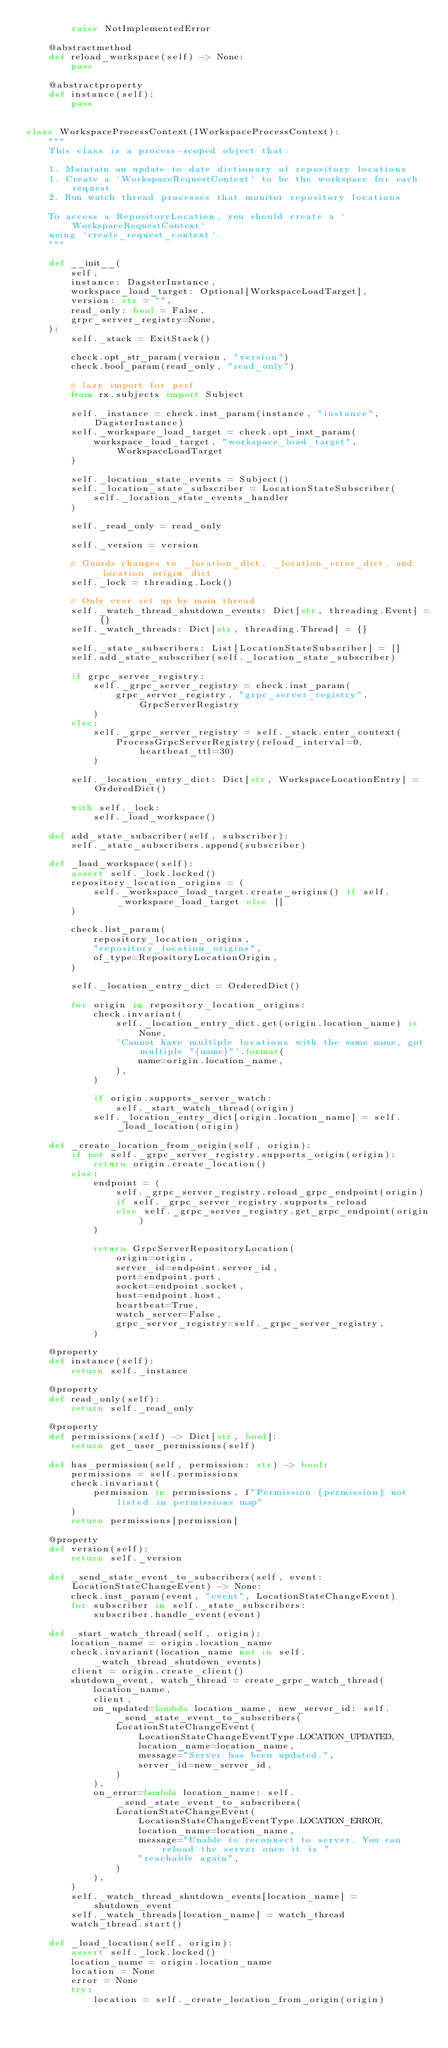<code> <loc_0><loc_0><loc_500><loc_500><_Python_>        raise NotImplementedError

    @abstractmethod
    def reload_workspace(self) -> None:
        pass

    @abstractproperty
    def instance(self):
        pass


class WorkspaceProcessContext(IWorkspaceProcessContext):
    """
    This class is a process-scoped object that:

    1. Maintain an update-to-date dictionary of repository locations
    1. Create a `WorkspaceRequestContext` to be the workspace for each request
    2. Run watch thread processes that monitor repository locations

    To access a RepositoryLocation, you should create a `WorkspaceRequestContext`
    using `create_request_context`.
    """

    def __init__(
        self,
        instance: DagsterInstance,
        workspace_load_target: Optional[WorkspaceLoadTarget],
        version: str = "",
        read_only: bool = False,
        grpc_server_registry=None,
    ):
        self._stack = ExitStack()

        check.opt_str_param(version, "version")
        check.bool_param(read_only, "read_only")

        # lazy import for perf
        from rx.subjects import Subject

        self._instance = check.inst_param(instance, "instance", DagsterInstance)
        self._workspace_load_target = check.opt_inst_param(
            workspace_load_target, "workspace_load_target", WorkspaceLoadTarget
        )

        self._location_state_events = Subject()
        self._location_state_subscriber = LocationStateSubscriber(
            self._location_state_events_handler
        )

        self._read_only = read_only

        self._version = version

        # Guards changes to _location_dict, _location_error_dict, and _location_origin_dict
        self._lock = threading.Lock()

        # Only ever set up by main thread
        self._watch_thread_shutdown_events: Dict[str, threading.Event] = {}
        self._watch_threads: Dict[str, threading.Thread] = {}

        self._state_subscribers: List[LocationStateSubscriber] = []
        self.add_state_subscriber(self._location_state_subscriber)

        if grpc_server_registry:
            self._grpc_server_registry = check.inst_param(
                grpc_server_registry, "grpc_server_registry", GrpcServerRegistry
            )
        else:
            self._grpc_server_registry = self._stack.enter_context(
                ProcessGrpcServerRegistry(reload_interval=0, heartbeat_ttl=30)
            )

        self._location_entry_dict: Dict[str, WorkspaceLocationEntry] = OrderedDict()

        with self._lock:
            self._load_workspace()

    def add_state_subscriber(self, subscriber):
        self._state_subscribers.append(subscriber)

    def _load_workspace(self):
        assert self._lock.locked()
        repository_location_origins = (
            self._workspace_load_target.create_origins() if self._workspace_load_target else []
        )

        check.list_param(
            repository_location_origins,
            "repository_location_origins",
            of_type=RepositoryLocationOrigin,
        )

        self._location_entry_dict = OrderedDict()

        for origin in repository_location_origins:
            check.invariant(
                self._location_entry_dict.get(origin.location_name) is None,
                'Cannot have multiple locations with the same name, got multiple "{name}"'.format(
                    name=origin.location_name,
                ),
            )

            if origin.supports_server_watch:
                self._start_watch_thread(origin)
            self._location_entry_dict[origin.location_name] = self._load_location(origin)

    def _create_location_from_origin(self, origin):
        if not self._grpc_server_registry.supports_origin(origin):
            return origin.create_location()
        else:
            endpoint = (
                self._grpc_server_registry.reload_grpc_endpoint(origin)
                if self._grpc_server_registry.supports_reload
                else self._grpc_server_registry.get_grpc_endpoint(origin)
            )

            return GrpcServerRepositoryLocation(
                origin=origin,
                server_id=endpoint.server_id,
                port=endpoint.port,
                socket=endpoint.socket,
                host=endpoint.host,
                heartbeat=True,
                watch_server=False,
                grpc_server_registry=self._grpc_server_registry,
            )

    @property
    def instance(self):
        return self._instance

    @property
    def read_only(self):
        return self._read_only

    @property
    def permissions(self) -> Dict[str, bool]:
        return get_user_permissions(self)

    def has_permission(self, permission: str) -> bool:
        permissions = self.permissions
        check.invariant(
            permission in permissions, f"Permission {permission} not listed in permissions map"
        )
        return permissions[permission]

    @property
    def version(self):
        return self._version

    def _send_state_event_to_subscribers(self, event: LocationStateChangeEvent) -> None:
        check.inst_param(event, "event", LocationStateChangeEvent)
        for subscriber in self._state_subscribers:
            subscriber.handle_event(event)

    def _start_watch_thread(self, origin):
        location_name = origin.location_name
        check.invariant(location_name not in self._watch_thread_shutdown_events)
        client = origin.create_client()
        shutdown_event, watch_thread = create_grpc_watch_thread(
            location_name,
            client,
            on_updated=lambda location_name, new_server_id: self._send_state_event_to_subscribers(
                LocationStateChangeEvent(
                    LocationStateChangeEventType.LOCATION_UPDATED,
                    location_name=location_name,
                    message="Server has been updated.",
                    server_id=new_server_id,
                )
            ),
            on_error=lambda location_name: self._send_state_event_to_subscribers(
                LocationStateChangeEvent(
                    LocationStateChangeEventType.LOCATION_ERROR,
                    location_name=location_name,
                    message="Unable to reconnect to server. You can reload the server once it is "
                    "reachable again",
                )
            ),
        )
        self._watch_thread_shutdown_events[location_name] = shutdown_event
        self._watch_threads[location_name] = watch_thread
        watch_thread.start()

    def _load_location(self, origin):
        assert self._lock.locked()
        location_name = origin.location_name
        location = None
        error = None
        try:
            location = self._create_location_from_origin(origin)</code> 